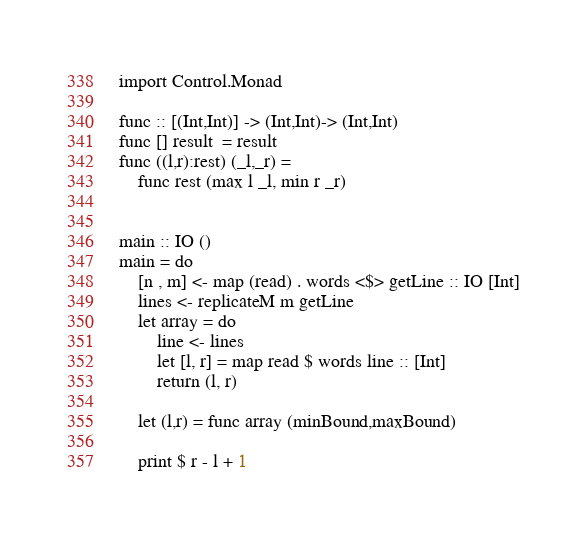Convert code to text. <code><loc_0><loc_0><loc_500><loc_500><_Haskell_>
import Control.Monad

func :: [(Int,Int)] -> (Int,Int)-> (Int,Int)
func [] result  = result
func ((l,r):rest) (_l,_r) =
    func rest (max l _l, min r _r)


main :: IO ()
main = do
    [n , m] <- map (read) . words <$> getLine :: IO [Int]
    lines <- replicateM m getLine 
    let array = do
        line <- lines
        let [l, r] = map read $ words line :: [Int]
        return (l, r)

    let (l,r) = func array (minBound,maxBound)
    
    print $ r - l + 1




</code> 